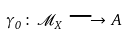<formula> <loc_0><loc_0><loc_500><loc_500>\gamma _ { 0 } \, \colon \, { \mathcal { M } } _ { X } \, \longrightarrow \, A</formula> 